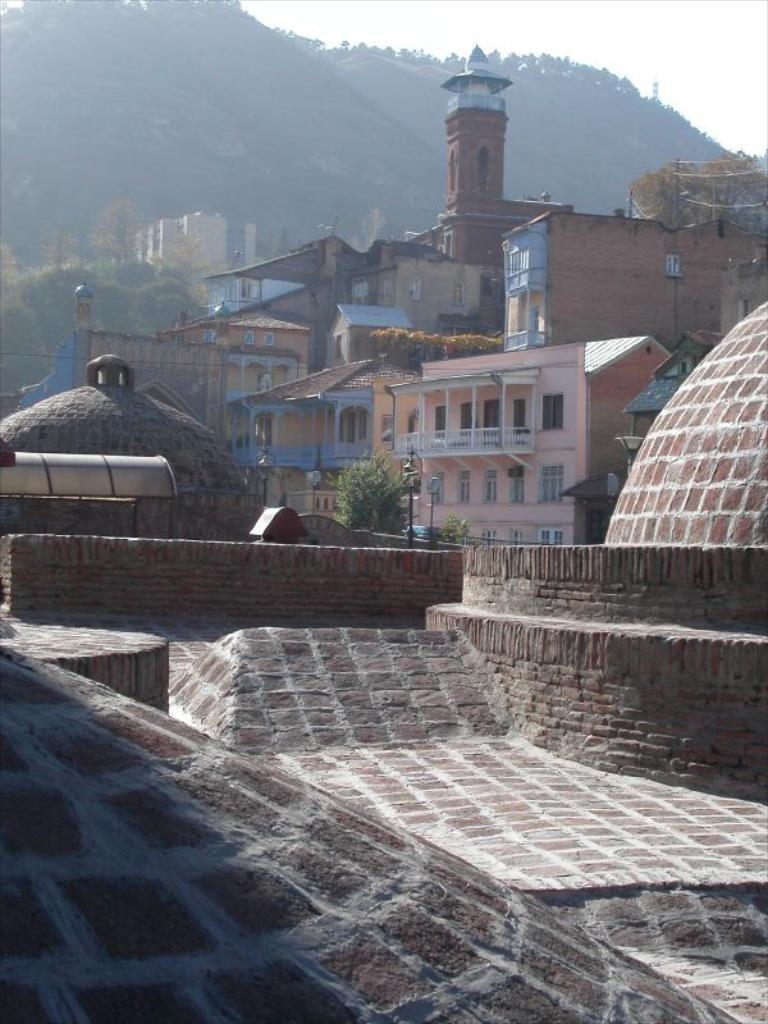What structures are in the foreground of the image? There is a dome and a slab of a building in the foreground of the image. How many domes can be seen in the image? There are two domes visible in the image. What can be seen in the background of the image? There are buildings, a cliff, trees, and the sky visible in the background of the image. What type of ray is visible in the image? There is no ray present in the image. What order of magnitude is the star in the image? There is no star present in the image. 